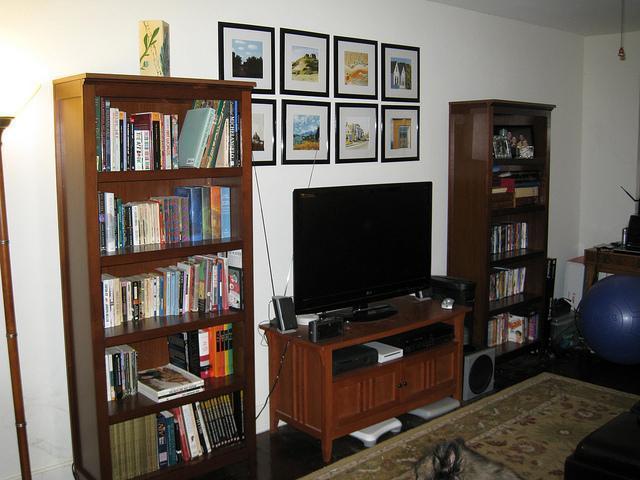What type of paint was used to paint the pictures hanging on the wall?
Choose the correct response and explain in the format: 'Answer: answer
Rationale: rationale.'
Options: Acrylic, gouache, watercolor, oil. Answer: watercolor.
Rationale: The paintings that are framed and hanging on the wall were made with watercolor paints. 